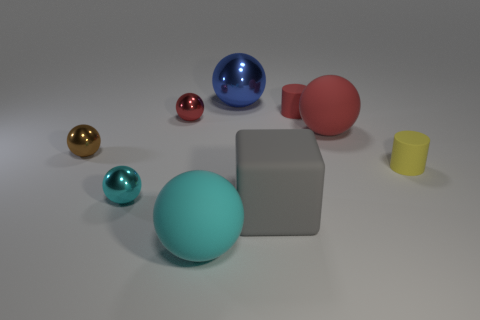Can you describe the shapes and materials of the objects visible in the image? In the image, there are seven objects with various shapes and materials. From the left, there is a small golden ball with a shiny metallic finish, a teal ball with a matte surface that might be rubber or plastic, and a large blue transparent ball resembling glass. In the background, there is an opaque red rubber ball. On the right, we see a small pink metallic ball, a large grey block likely made of a matte material like stone or concrete, and a small yellow cup with a matte surface. 